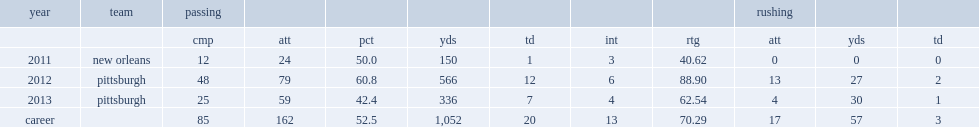How many passes did derek cassidy complete in 2012? 48.0. 